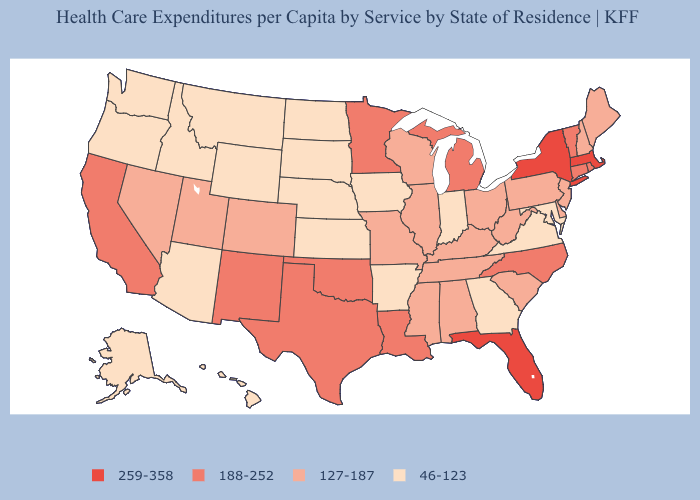Which states have the highest value in the USA?
Quick response, please. Florida, Massachusetts, New York. Does Louisiana have a higher value than West Virginia?
Concise answer only. Yes. How many symbols are there in the legend?
Quick response, please. 4. What is the lowest value in the Northeast?
Answer briefly. 127-187. Is the legend a continuous bar?
Quick response, please. No. What is the value of Illinois?
Quick response, please. 127-187. What is the value of Minnesota?
Short answer required. 188-252. Does Kentucky have a lower value than Oklahoma?
Write a very short answer. Yes. Name the states that have a value in the range 46-123?
Be succinct. Alaska, Arizona, Arkansas, Georgia, Hawaii, Idaho, Indiana, Iowa, Kansas, Maryland, Montana, Nebraska, North Dakota, Oregon, South Dakota, Virginia, Washington, Wyoming. What is the value of Virginia?
Write a very short answer. 46-123. What is the value of Maryland?
Give a very brief answer. 46-123. What is the value of Pennsylvania?
Keep it brief. 127-187. What is the highest value in states that border Delaware?
Give a very brief answer. 127-187. Which states have the lowest value in the USA?
Write a very short answer. Alaska, Arizona, Arkansas, Georgia, Hawaii, Idaho, Indiana, Iowa, Kansas, Maryland, Montana, Nebraska, North Dakota, Oregon, South Dakota, Virginia, Washington, Wyoming. Which states have the highest value in the USA?
Keep it brief. Florida, Massachusetts, New York. 